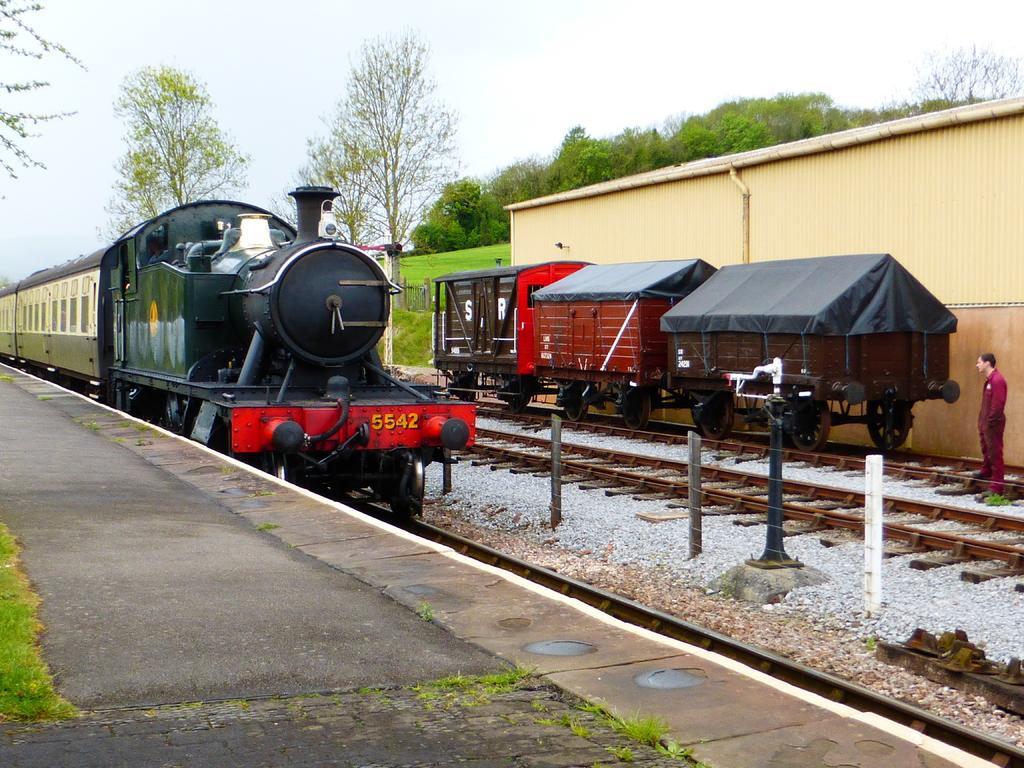Could you give a brief overview of what you see in this image? In this image, we can see a train is on the track. Here we can see few tracks. At the bottom, there is a platform. Here we can see few containers. Right side of the image, we can see a person is standing. Background there are so many trees, plants, grass. Top of the image, there is a sky. 